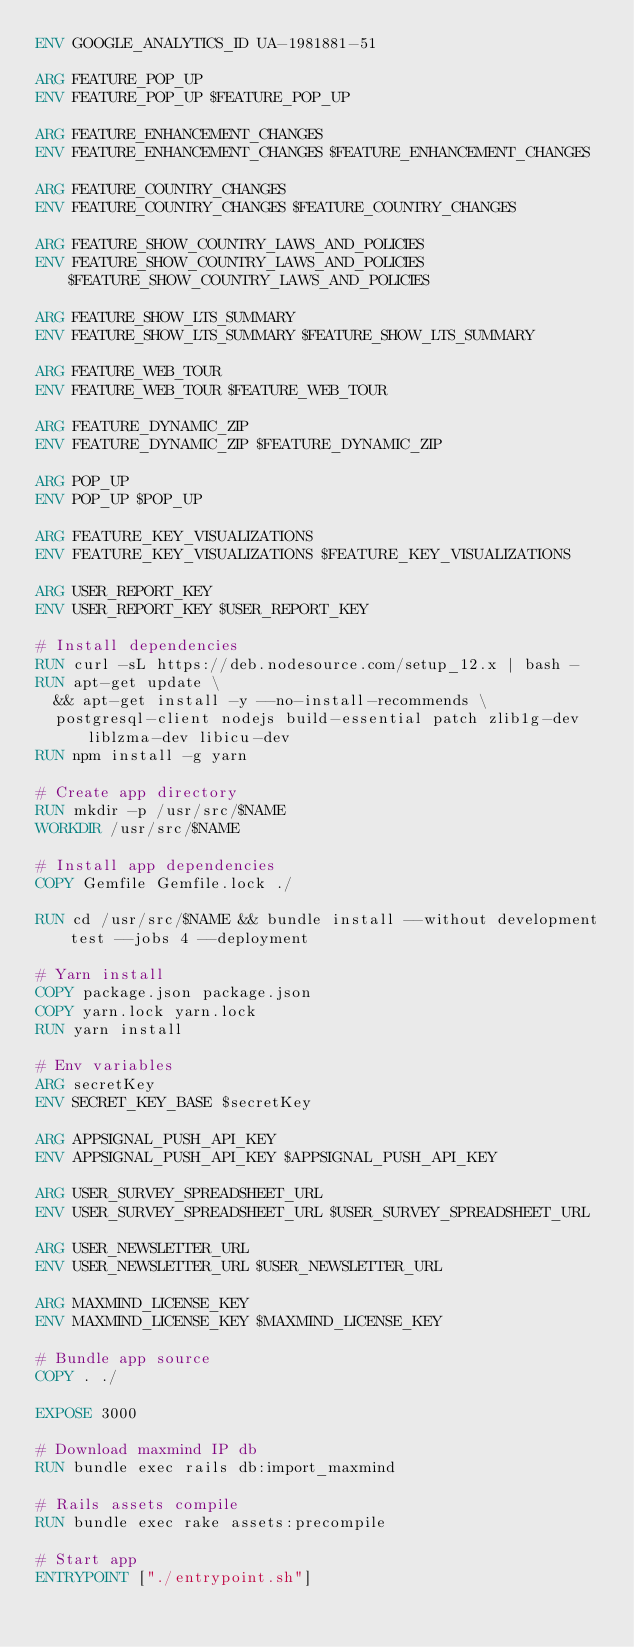Convert code to text. <code><loc_0><loc_0><loc_500><loc_500><_Dockerfile_>ENV GOOGLE_ANALYTICS_ID UA-1981881-51

ARG FEATURE_POP_UP
ENV FEATURE_POP_UP $FEATURE_POP_UP

ARG FEATURE_ENHANCEMENT_CHANGES
ENV FEATURE_ENHANCEMENT_CHANGES $FEATURE_ENHANCEMENT_CHANGES

ARG FEATURE_COUNTRY_CHANGES
ENV FEATURE_COUNTRY_CHANGES $FEATURE_COUNTRY_CHANGES

ARG FEATURE_SHOW_COUNTRY_LAWS_AND_POLICIES
ENV FEATURE_SHOW_COUNTRY_LAWS_AND_POLICIES $FEATURE_SHOW_COUNTRY_LAWS_AND_POLICIES

ARG FEATURE_SHOW_LTS_SUMMARY
ENV FEATURE_SHOW_LTS_SUMMARY $FEATURE_SHOW_LTS_SUMMARY

ARG FEATURE_WEB_TOUR
ENV FEATURE_WEB_TOUR $FEATURE_WEB_TOUR

ARG FEATURE_DYNAMIC_ZIP
ENV FEATURE_DYNAMIC_ZIP $FEATURE_DYNAMIC_ZIP

ARG POP_UP
ENV POP_UP $POP_UP

ARG FEATURE_KEY_VISUALIZATIONS
ENV FEATURE_KEY_VISUALIZATIONS $FEATURE_KEY_VISUALIZATIONS

ARG USER_REPORT_KEY
ENV USER_REPORT_KEY $USER_REPORT_KEY

# Install dependencies
RUN curl -sL https://deb.nodesource.com/setup_12.x | bash -
RUN apt-get update \
  && apt-get install -y --no-install-recommends \
  postgresql-client nodejs build-essential patch zlib1g-dev liblzma-dev libicu-dev
RUN npm install -g yarn

# Create app directory
RUN mkdir -p /usr/src/$NAME
WORKDIR /usr/src/$NAME

# Install app dependencies
COPY Gemfile Gemfile.lock ./

RUN cd /usr/src/$NAME && bundle install --without development test --jobs 4 --deployment

# Yarn install
COPY package.json package.json
COPY yarn.lock yarn.lock
RUN yarn install

# Env variables
ARG secretKey
ENV SECRET_KEY_BASE $secretKey

ARG APPSIGNAL_PUSH_API_KEY
ENV APPSIGNAL_PUSH_API_KEY $APPSIGNAL_PUSH_API_KEY

ARG USER_SURVEY_SPREADSHEET_URL
ENV USER_SURVEY_SPREADSHEET_URL $USER_SURVEY_SPREADSHEET_URL

ARG USER_NEWSLETTER_URL
ENV USER_NEWSLETTER_URL $USER_NEWSLETTER_URL

ARG MAXMIND_LICENSE_KEY
ENV MAXMIND_LICENSE_KEY $MAXMIND_LICENSE_KEY

# Bundle app source
COPY . ./

EXPOSE 3000

# Download maxmind IP db
RUN bundle exec rails db:import_maxmind

# Rails assets compile
RUN bundle exec rake assets:precompile

# Start app
ENTRYPOINT ["./entrypoint.sh"]
</code> 